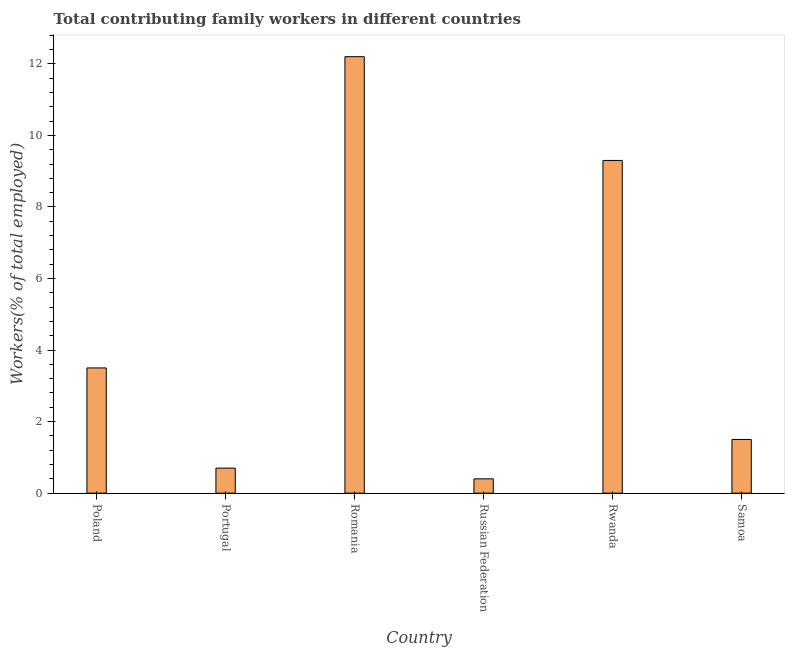What is the title of the graph?
Provide a short and direct response. Total contributing family workers in different countries. What is the label or title of the X-axis?
Ensure brevity in your answer.  Country. What is the label or title of the Y-axis?
Your answer should be very brief. Workers(% of total employed). What is the contributing family workers in Romania?
Provide a succinct answer. 12.2. Across all countries, what is the maximum contributing family workers?
Keep it short and to the point. 12.2. Across all countries, what is the minimum contributing family workers?
Make the answer very short. 0.4. In which country was the contributing family workers maximum?
Offer a terse response. Romania. In which country was the contributing family workers minimum?
Your answer should be compact. Russian Federation. What is the sum of the contributing family workers?
Give a very brief answer. 27.6. In how many countries, is the contributing family workers greater than 12.4 %?
Provide a succinct answer. 0. What is the ratio of the contributing family workers in Poland to that in Romania?
Ensure brevity in your answer.  0.29. Is the difference between the contributing family workers in Romania and Rwanda greater than the difference between any two countries?
Provide a succinct answer. No. What is the difference between the highest and the lowest contributing family workers?
Give a very brief answer. 11.8. In how many countries, is the contributing family workers greater than the average contributing family workers taken over all countries?
Your answer should be very brief. 2. How many bars are there?
Offer a terse response. 6. Are all the bars in the graph horizontal?
Offer a terse response. No. What is the difference between two consecutive major ticks on the Y-axis?
Your response must be concise. 2. Are the values on the major ticks of Y-axis written in scientific E-notation?
Offer a terse response. No. What is the Workers(% of total employed) in Portugal?
Make the answer very short. 0.7. What is the Workers(% of total employed) in Romania?
Your answer should be very brief. 12.2. What is the Workers(% of total employed) of Russian Federation?
Provide a succinct answer. 0.4. What is the Workers(% of total employed) of Rwanda?
Make the answer very short. 9.3. What is the Workers(% of total employed) in Samoa?
Ensure brevity in your answer.  1.5. What is the difference between the Workers(% of total employed) in Poland and Romania?
Keep it short and to the point. -8.7. What is the difference between the Workers(% of total employed) in Poland and Samoa?
Provide a short and direct response. 2. What is the difference between the Workers(% of total employed) in Portugal and Romania?
Your response must be concise. -11.5. What is the difference between the Workers(% of total employed) in Romania and Rwanda?
Keep it short and to the point. 2.9. What is the difference between the Workers(% of total employed) in Romania and Samoa?
Ensure brevity in your answer.  10.7. What is the difference between the Workers(% of total employed) in Russian Federation and Rwanda?
Your answer should be very brief. -8.9. What is the ratio of the Workers(% of total employed) in Poland to that in Portugal?
Your response must be concise. 5. What is the ratio of the Workers(% of total employed) in Poland to that in Romania?
Your response must be concise. 0.29. What is the ratio of the Workers(% of total employed) in Poland to that in Russian Federation?
Your answer should be compact. 8.75. What is the ratio of the Workers(% of total employed) in Poland to that in Rwanda?
Make the answer very short. 0.38. What is the ratio of the Workers(% of total employed) in Poland to that in Samoa?
Offer a very short reply. 2.33. What is the ratio of the Workers(% of total employed) in Portugal to that in Romania?
Your response must be concise. 0.06. What is the ratio of the Workers(% of total employed) in Portugal to that in Rwanda?
Provide a short and direct response. 0.07. What is the ratio of the Workers(% of total employed) in Portugal to that in Samoa?
Provide a succinct answer. 0.47. What is the ratio of the Workers(% of total employed) in Romania to that in Russian Federation?
Your answer should be very brief. 30.5. What is the ratio of the Workers(% of total employed) in Romania to that in Rwanda?
Provide a succinct answer. 1.31. What is the ratio of the Workers(% of total employed) in Romania to that in Samoa?
Your answer should be compact. 8.13. What is the ratio of the Workers(% of total employed) in Russian Federation to that in Rwanda?
Offer a very short reply. 0.04. What is the ratio of the Workers(% of total employed) in Russian Federation to that in Samoa?
Your answer should be compact. 0.27. What is the ratio of the Workers(% of total employed) in Rwanda to that in Samoa?
Provide a short and direct response. 6.2. 